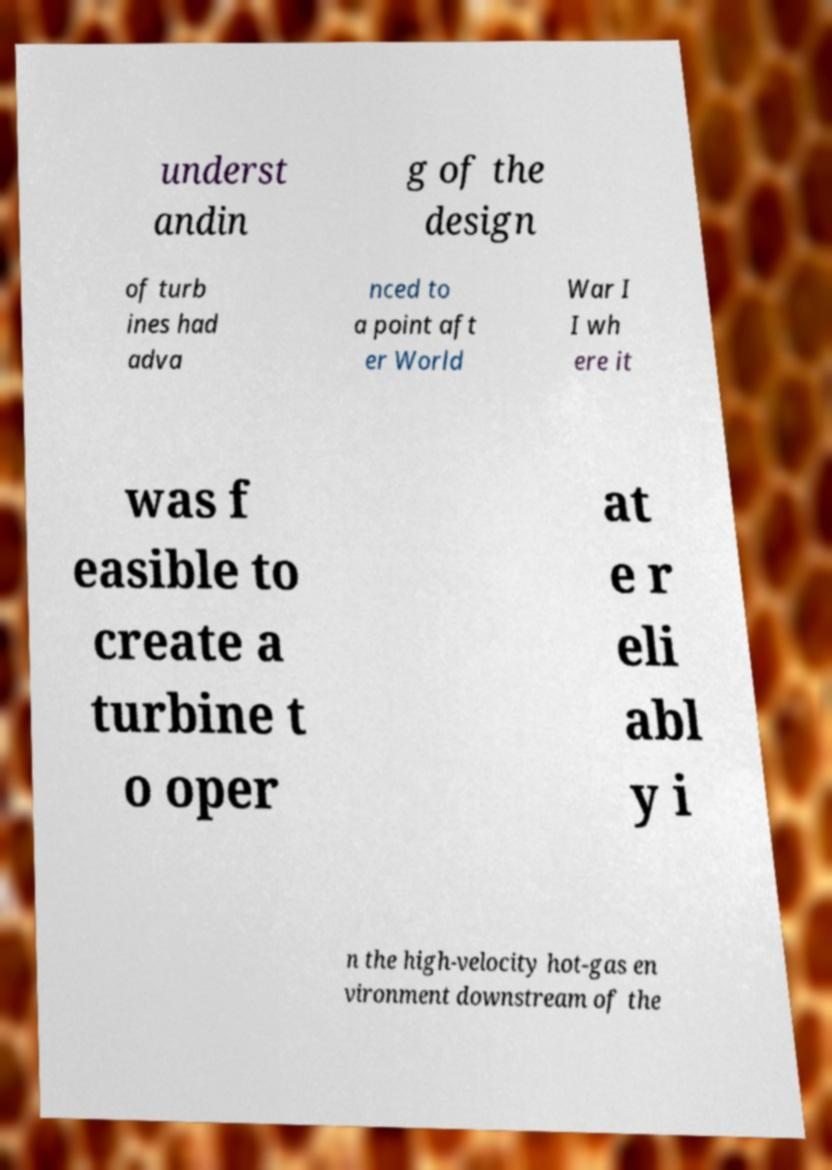Can you read and provide the text displayed in the image?This photo seems to have some interesting text. Can you extract and type it out for me? underst andin g of the design of turb ines had adva nced to a point aft er World War I I wh ere it was f easible to create a turbine t o oper at e r eli abl y i n the high-velocity hot-gas en vironment downstream of the 